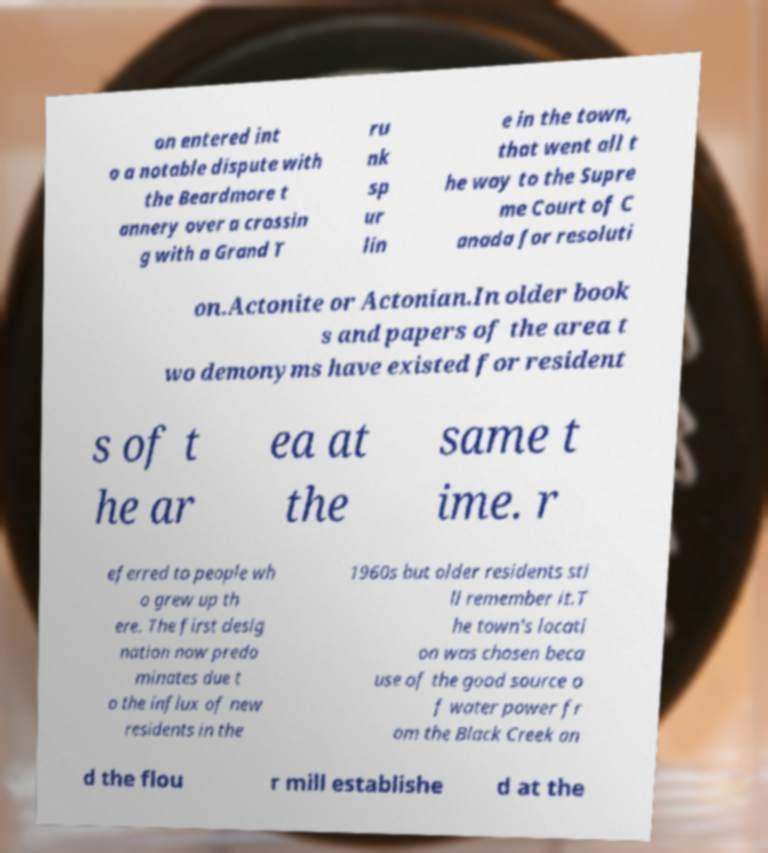Please identify and transcribe the text found in this image. on entered int o a notable dispute with the Beardmore t annery over a crossin g with a Grand T ru nk sp ur lin e in the town, that went all t he way to the Supre me Court of C anada for resoluti on.Actonite or Actonian.In older book s and papers of the area t wo demonyms have existed for resident s of t he ar ea at the same t ime. r eferred to people wh o grew up th ere. The first desig nation now predo minates due t o the influx of new residents in the 1960s but older residents sti ll remember it.T he town's locati on was chosen beca use of the good source o f water power fr om the Black Creek an d the flou r mill establishe d at the 